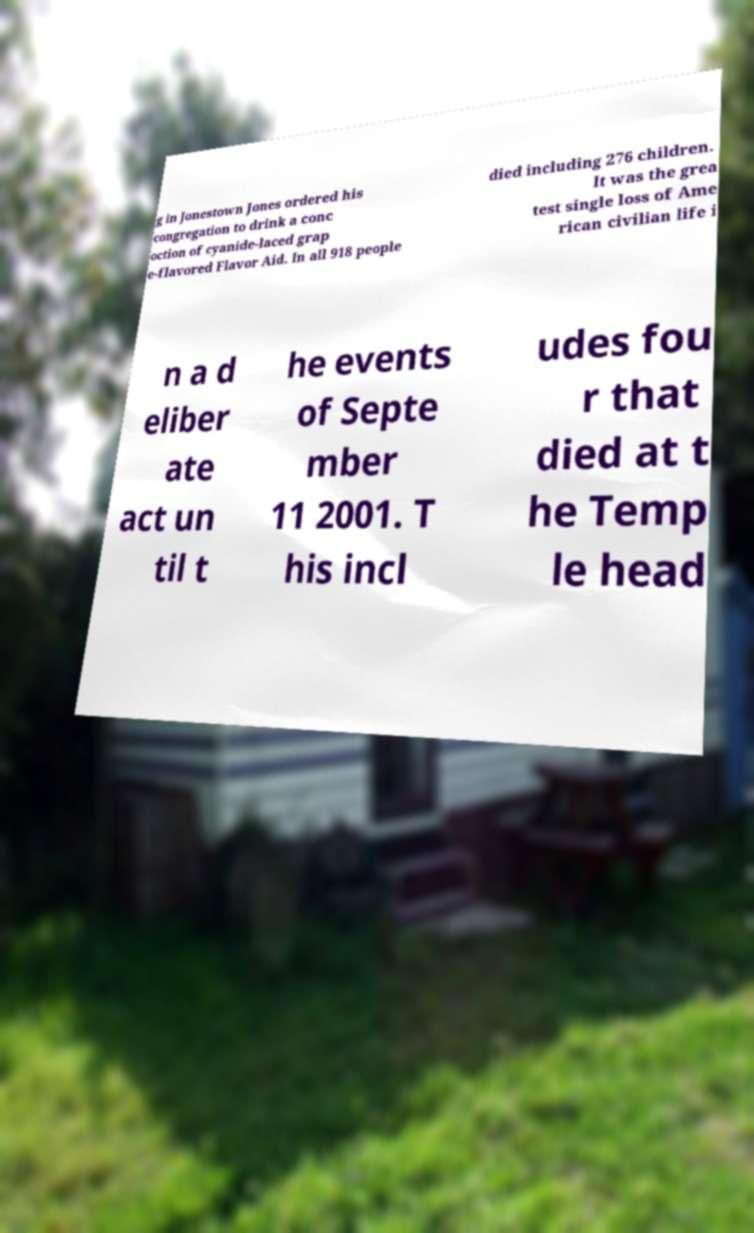Could you assist in decoding the text presented in this image and type it out clearly? g in Jonestown Jones ordered his congregation to drink a conc oction of cyanide-laced grap e-flavored Flavor Aid. In all 918 people died including 276 children. It was the grea test single loss of Ame rican civilian life i n a d eliber ate act un til t he events of Septe mber 11 2001. T his incl udes fou r that died at t he Temp le head 